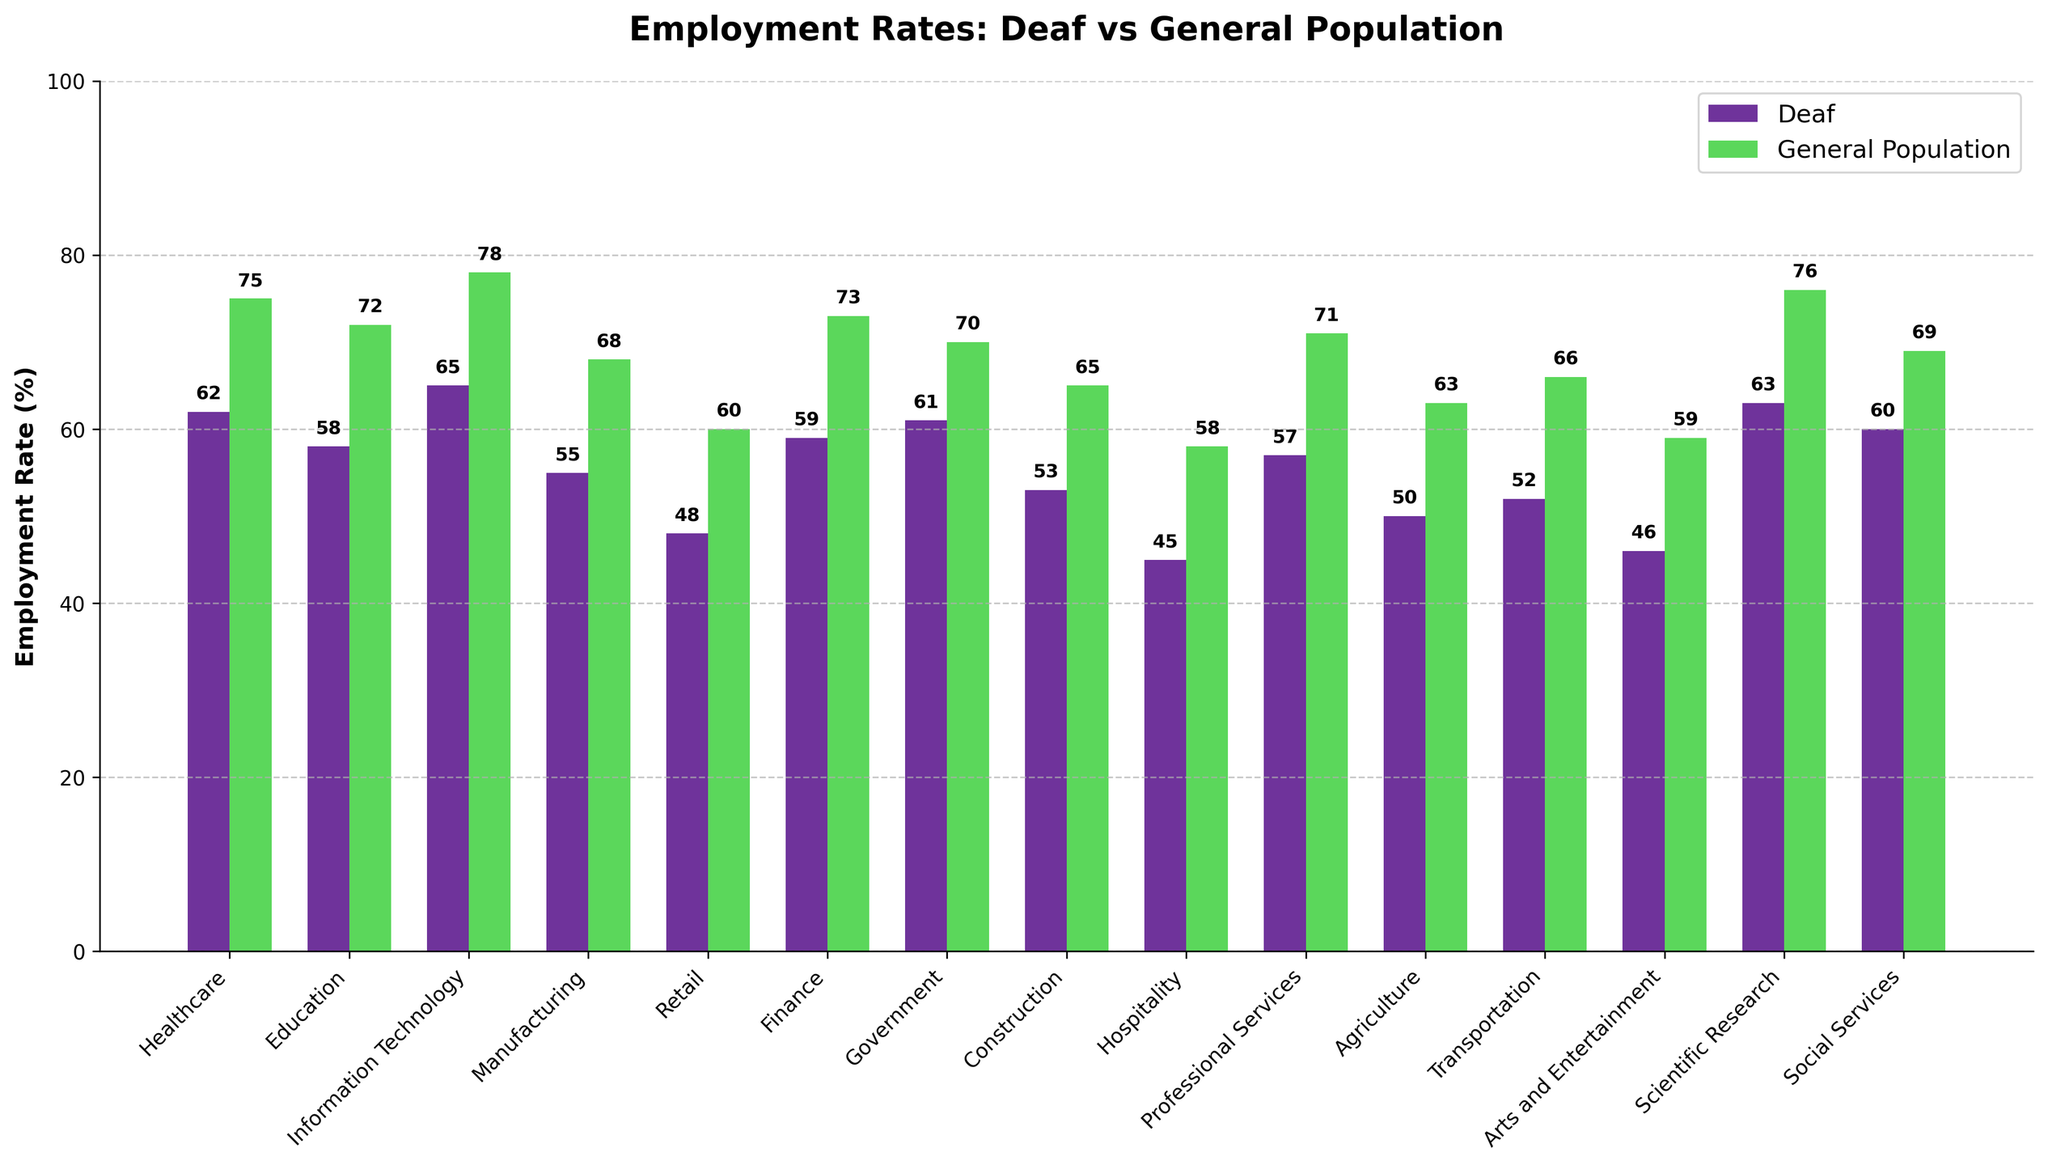Which job sector has the highest employment rate for the general population? By examining the heights of the bars labeled with "General Population," the tallest bar represents the Information Technology sector.
Answer: Information Technology What is the difference in employment rates between Deaf individuals and the general population in the Healthcare sector? The employment rate for Deaf individuals in Healthcare is 62%, and for the general population, it is 75%. Subtracting the two gives 75 - 62 = 13.
Answer: 13 Which job sector shows the smallest gap in employment rates between Deaf individuals and the general population? By comparing the gaps visually across all sectors, the Healthcare sector shows the smallest gap as the difference is less noticeable.
Answer: Healthcare What is the overall average employment rate for Deaf individuals across all job sectors? Sum all the employment rates for the Deaf individuals and divide by the number of job sectors: (62 + 58 + 65 + 55 + 48 + 59 + 61 + 53 + 45 + 57 + 50 + 52 + 46 + 63 + 60) / 15 = 858 / 15 = 57.2.
Answer: 57.2 In which job sector is the employment rate for Deaf individuals more than 10% lower than the general population? Look for sectors where the difference between the general population and Deaf individuals is greater than 10%. Sectors include Retail, Manufacturing, and Hospitality, among others.
Answer: Retail, Manufacturing, Hospitality (any one of these) What is the combined employment rate of Deaf individuals in Education, Finance, and Construction sectors? Add the employment rates for Deaf individuals in the mentioned sectors: 58 + 59 + 53 = 170.
Answer: 170 Which sector has a higher employment rate for Deaf individuals compared to other sectors, but not the highest for the general population? Comparing heights, the Scientific Research sector has a relatively high employment rate for Deaf individuals (63%) but does not have the highest rate for the general population.
Answer: Scientific Research Which two job sectors have the lowest employment rates for Deaf individuals? By examining the shortest bars for Deaf individuals, the Hospitality (45%) and Arts and Entertainment (46%) sectors have the lowest employment rates.
Answer: Hospitality and Arts and Entertainment What is the average employment rate difference between Deaf individuals and the general population across all sectors? Calculate the difference for each sector, sum them, and divide by the number of sectors: (75-62) + (72-58) + (78-65) + (68-55) + (60-48) + (73-59) + (70-61) + (65-53) + (58-45) + (71-57) + (63-50) + (66-52) + (59-46) + (76-63) + (69-60) = 15 + 14 + 13 + 13 + 12 + 14 + 9 + 12 + 13 + 14 + 13 + 14 + 13 + 13 + 9 = 199. Then, 199 / 15 = 13.27.
Answer: 13.27 